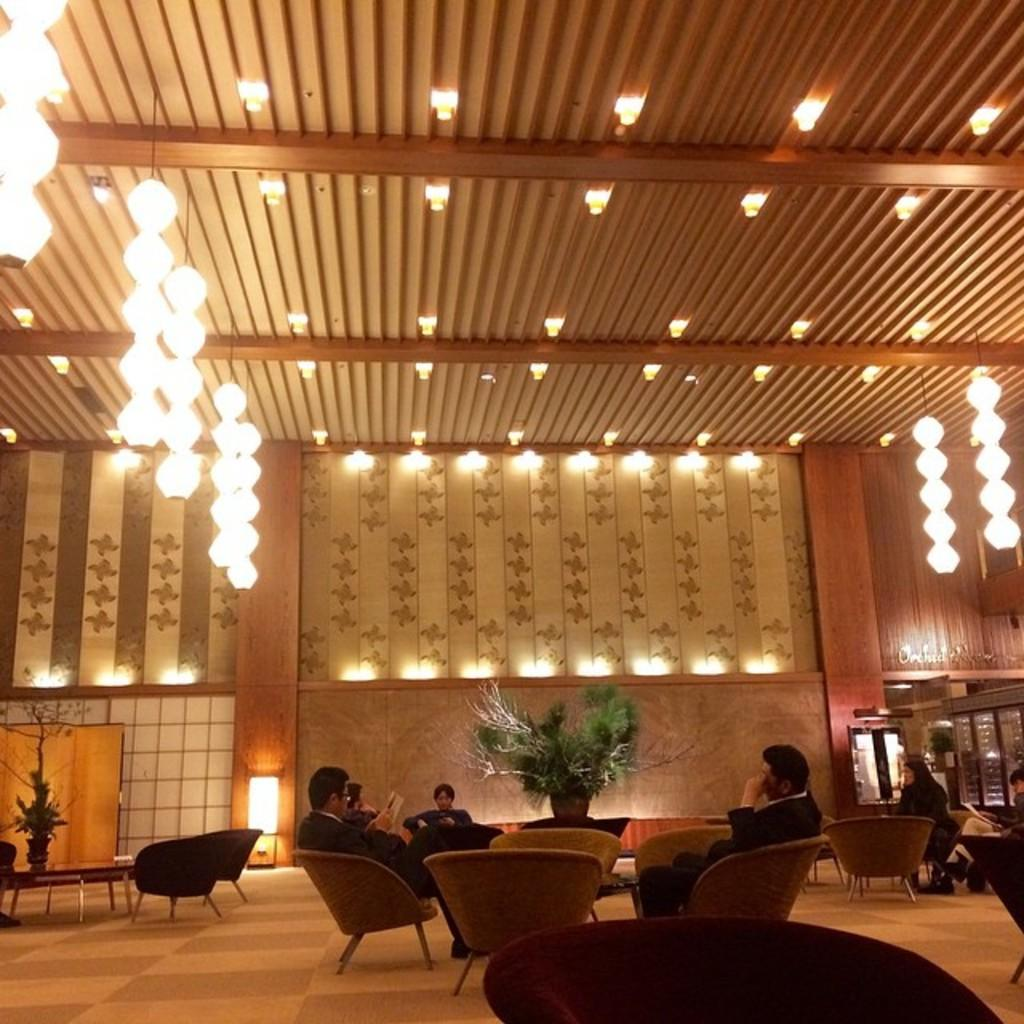What are the people in the image doing? The people in the image are sitting in chairs. What can be seen behind the people? There is a wall in the background of the image. What is visible above the people? There is a ceiling with lights at the top of the image. What is the size of the sky in the image? There is no sky present in the image, as it is an indoor setting with a ceiling. 